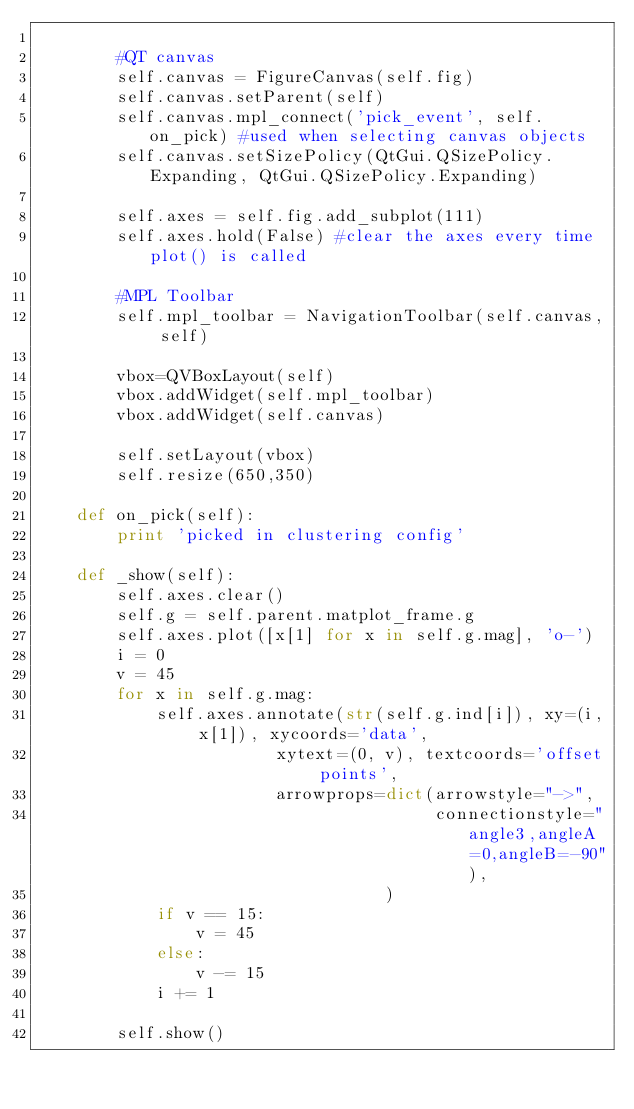Convert code to text. <code><loc_0><loc_0><loc_500><loc_500><_Python_>        
        #QT canvas
        self.canvas = FigureCanvas(self.fig)
        self.canvas.setParent(self)
        self.canvas.mpl_connect('pick_event', self.on_pick) #used when selecting canvas objects
        self.canvas.setSizePolicy(QtGui.QSizePolicy.Expanding, QtGui.QSizePolicy.Expanding) 
        
        self.axes = self.fig.add_subplot(111)
        self.axes.hold(False) #clear the axes every time plot() is called

        #MPL Toolbar
        self.mpl_toolbar = NavigationToolbar(self.canvas, self)
        
        vbox=QVBoxLayout(self)
        vbox.addWidget(self.mpl_toolbar)
        vbox.addWidget(self.canvas)
        
        self.setLayout(vbox)
        self.resize(650,350)

    def on_pick(self):
        print 'picked in clustering config'

    def _show(self):
        self.axes.clear()
        self.g = self.parent.matplot_frame.g
        self.axes.plot([x[1] for x in self.g.mag], 'o-')
        i = 0
        v = 45
        for x in self.g.mag:
            self.axes.annotate(str(self.g.ind[i]), xy=(i, x[1]), xycoords='data',
                        xytext=(0, v), textcoords='offset points',
                        arrowprops=dict(arrowstyle="->",
                                        connectionstyle="angle3,angleA=0,angleB=-90"),
                                   )
            if v == 15:
                v = 45
            else:
                v -= 15
            i += 1
            
        self.show()
</code> 